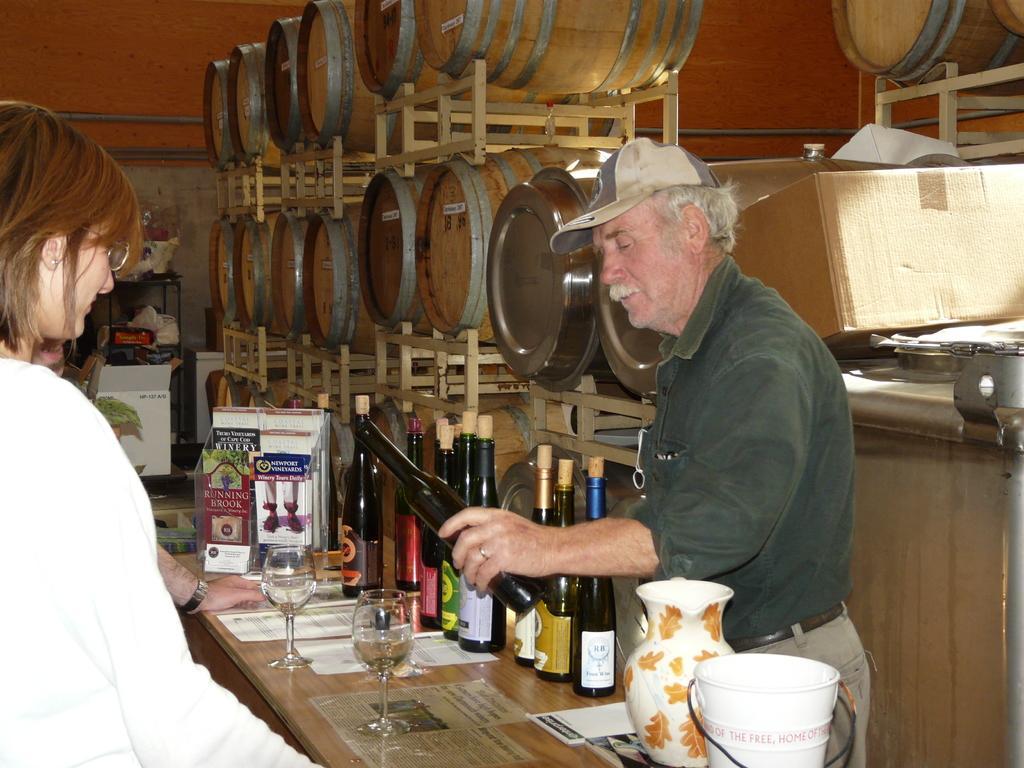In one or two sentences, can you explain what this image depicts? There are two people standing on the either sides of the table. On the table there are wine bottles, wine glasses, papers, vase, bucket and a small box. The man standing on the right side is holding a bottle and serving the drink. Behind him there are cardboard boxes and barrels in the racks. In the background there is wall. 